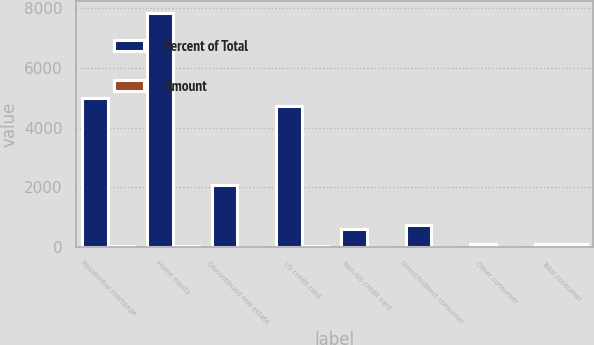<chart> <loc_0><loc_0><loc_500><loc_500><stacked_bar_chart><ecel><fcel>Residential mortgage<fcel>Home equity<fcel>Discontinued real estate<fcel>US credit card<fcel>Non-US credit card<fcel>Direct/Indirect consumer<fcel>Other consumer<fcel>Total consumer<nl><fcel>Percent of Total<fcel>5004<fcel>7845<fcel>2084<fcel>4718<fcel>600<fcel>718<fcel>104<fcel>87.15<nl><fcel>Amount<fcel>20.69<fcel>32.45<fcel>8.62<fcel>19.51<fcel>2.48<fcel>2.97<fcel>0.43<fcel>87.15<nl></chart> 